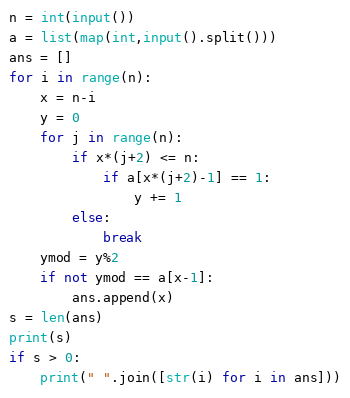Convert code to text. <code><loc_0><loc_0><loc_500><loc_500><_Python_>n = int(input())
a = list(map(int,input().split()))
ans = []
for i in range(n):
    x = n-i
    y = 0
    for j in range(n):
        if x*(j+2) <= n:
            if a[x*(j+2)-1] == 1:
                y += 1
        else:
            break
    ymod = y%2
    if not ymod == a[x-1]:
        ans.append(x)
s = len(ans)
print(s)
if s > 0:
    print(" ".join([str(i) for i in ans]))</code> 